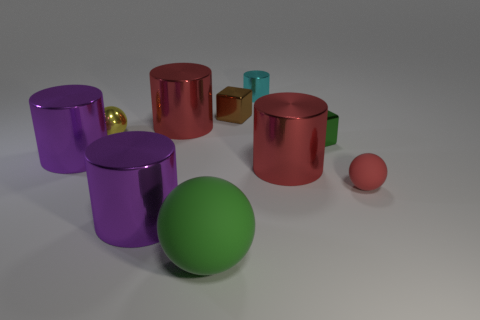What is the red object to the left of the cyan object? The red object is a glossy ceramic mug. Its reflective surface and rounded shape give it a sleek and smooth appearance. How does the lighting in the scene affect the appearance of the objects? The lighting in the scene is soft and diffused, creating subtle shadows and soft reflections on the objects, enhancing the perception of their textures and materials. 